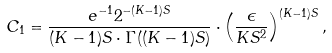Convert formula to latex. <formula><loc_0><loc_0><loc_500><loc_500>C _ { 1 } = \frac { e ^ { - 1 } 2 ^ { - ( K - 1 ) S } } { ( K - 1 ) S \cdot \Gamma ( ( K - 1 ) S ) } \cdot \left ( \frac { \epsilon } { K S ^ { 2 } } \right ) ^ { ( K - 1 ) S } ,</formula> 